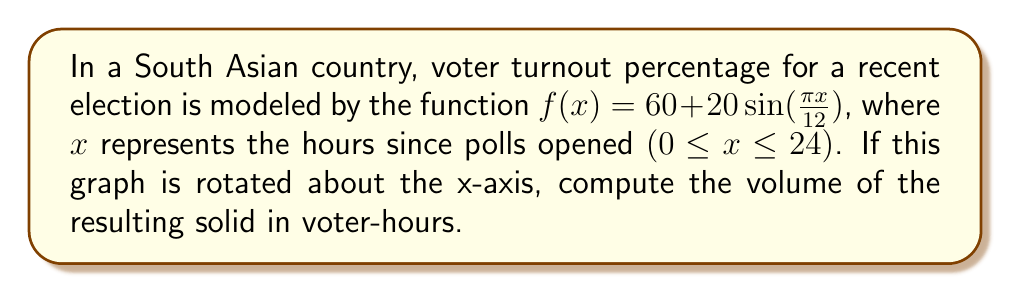What is the answer to this math problem? To solve this problem, we'll use the disk method for calculating the volume of a solid of revolution:

1) The formula for the volume is:
   $$V = \pi \int_a^b [f(x)]^2 dx$$

2) In this case, $a = 0$, $b = 24$, and $f(x) = 60 + 20\sin(\frac{\pi x}{12})$

3) Substituting into the formula:
   $$V = \pi \int_0^{24} [60 + 20\sin(\frac{\pi x}{12})]^2 dx$$

4) Expand the squared term:
   $$V = \pi \int_0^{24} [3600 + 2400\sin(\frac{\pi x}{12}) + 400\sin^2(\frac{\pi x}{12})] dx$$

5) Integrate each term:
   - $\int 3600 dx = 3600x$
   - $\int 2400\sin(\frac{\pi x}{12}) dx = -28800\cos(\frac{\pi x}{12})$
   - $\int 400\sin^2(\frac{\pi x}{12}) dx = 200x - 1200\sin(\frac{\pi x}{6})$

6) Apply the limits:
   $$V = \pi [3600x - 28800\cos(\frac{\pi x}{12}) + 200x - 1200\sin(\frac{\pi x}{6})]_0^{24}$$

7) Evaluate:
   $$V = \pi [(3600 \cdot 24 - 28800 \cdot 1 + 200 \cdot 24 - 1200 \cdot 0) - (0 - 28800 \cdot 1 + 0 - 0)]$$
   $$V = \pi [86400 - 28800 + 4800 + 28800]$$
   $$V = \pi [91200]$$
   $$V = 286514.56$$

Therefore, the volume is approximately 286,514.56 voter-hours.
Answer: 286,514.56 voter-hours 